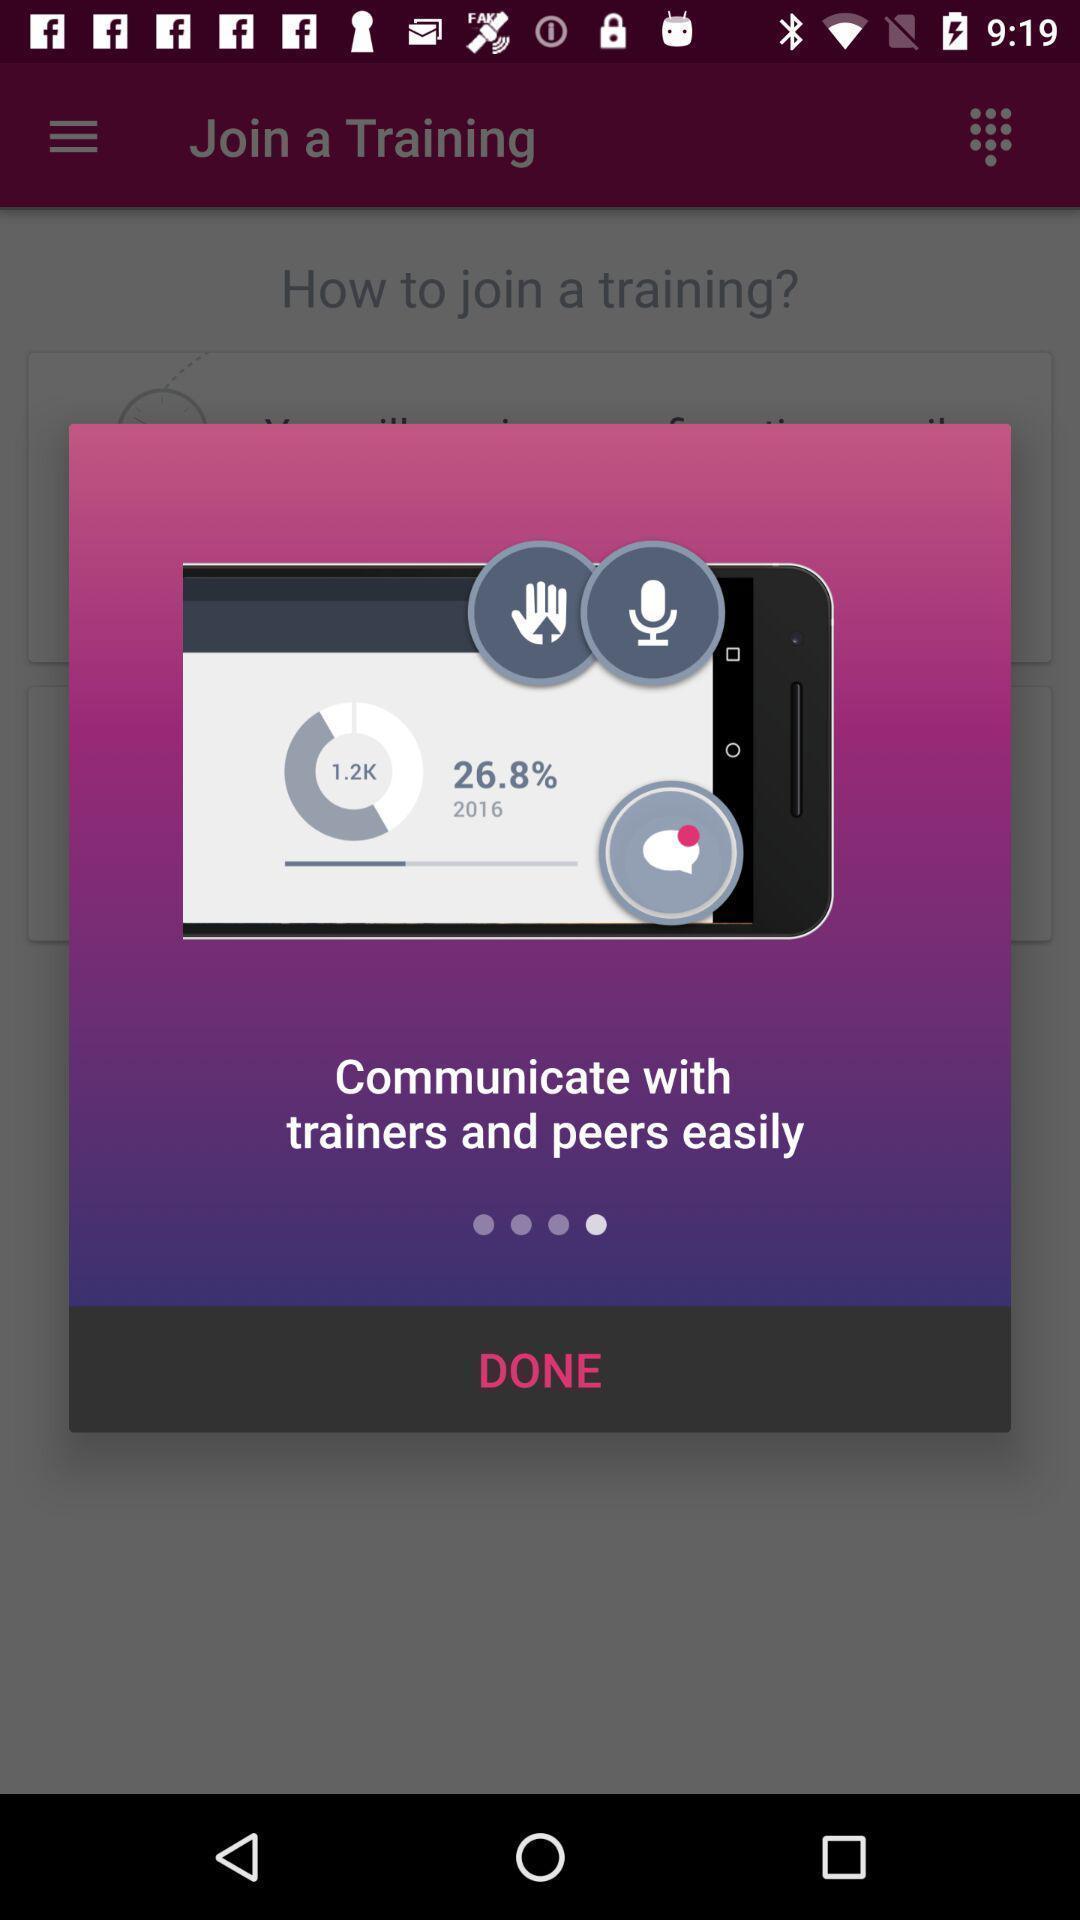Describe the key features of this screenshot. Popup showing the introductory info. 